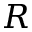<formula> <loc_0><loc_0><loc_500><loc_500>R</formula> 